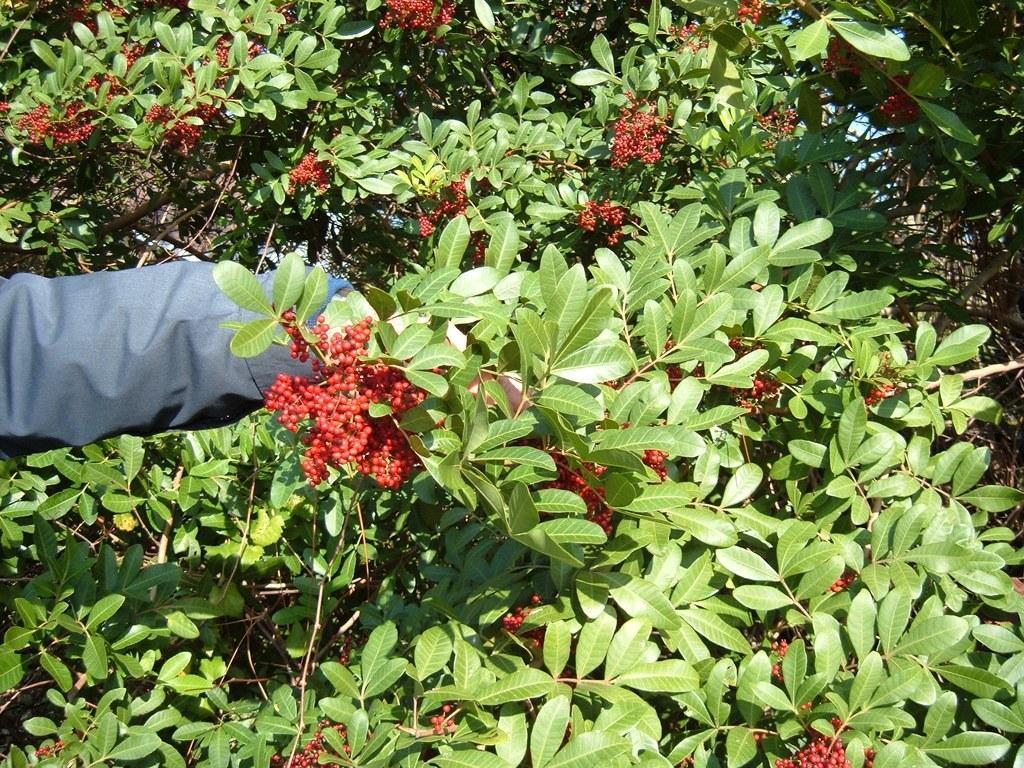Describe this image in one or two sentences. In this image I can see a few red color fruits and few green color leaves. I can see a blue color cloth. 